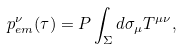Convert formula to latex. <formula><loc_0><loc_0><loc_500><loc_500>p _ { e m } ^ { \nu } ( \tau ) = P \int _ { \Sigma } d \sigma _ { \mu } T ^ { \mu \nu } ,</formula> 